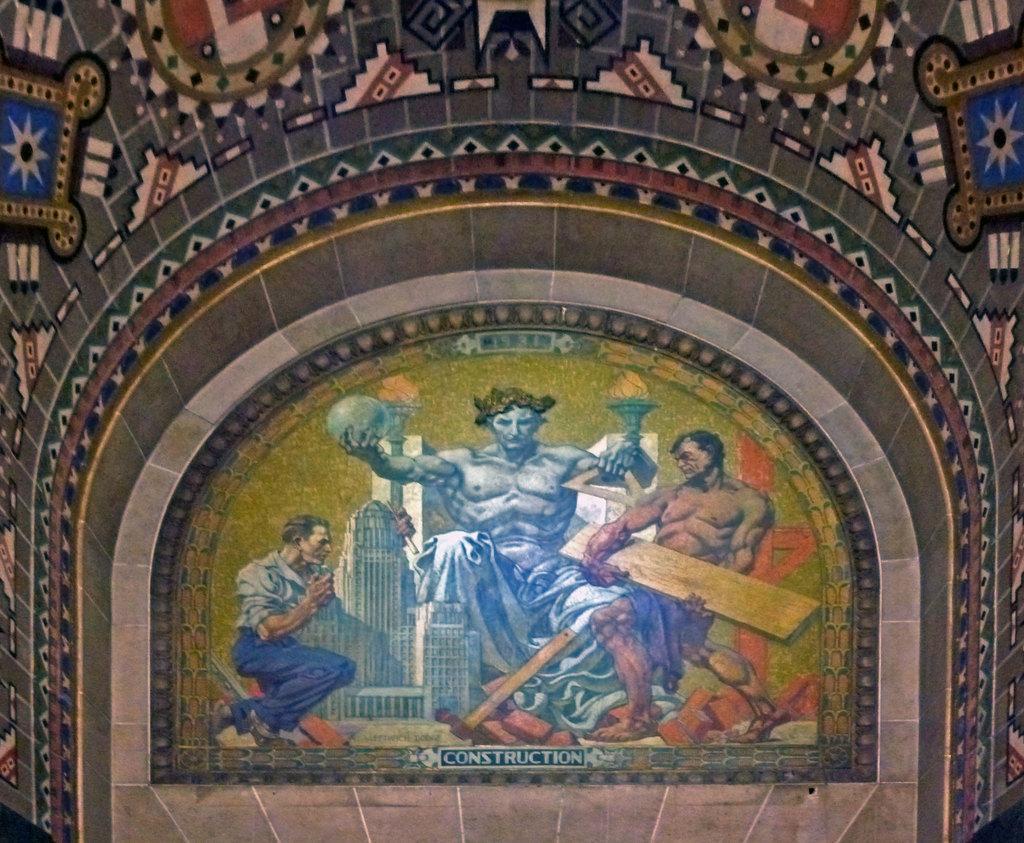Can you describe this image briefly? In the picture we can see some painting to the wall, in that we can see a man sitting on the chair and holding a globe and a fire, beside him we can see another person sitting and holding a wooden plank, and the left hand side we can see a person sitting on the knee. 